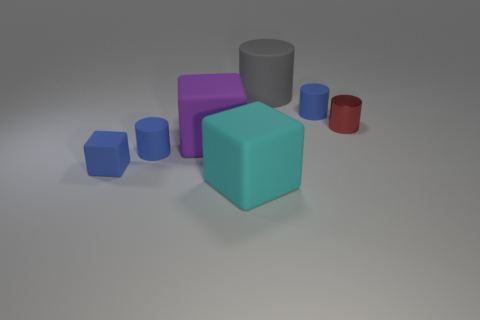Is there another large thing of the same shape as the big purple matte thing?
Your answer should be compact. Yes. How many large purple objects are there?
Give a very brief answer. 1. What shape is the large purple matte thing?
Your answer should be compact. Cube. What number of other objects have the same size as the red metal thing?
Ensure brevity in your answer.  3. Does the large purple matte object have the same shape as the gray matte object?
Give a very brief answer. No. What is the color of the block behind the tiny blue cylinder that is to the left of the purple matte block?
Give a very brief answer. Purple. There is a block that is both in front of the large purple matte cube and behind the large cyan rubber cube; what is its size?
Your response must be concise. Small. Is there any other thing that has the same color as the small cube?
Ensure brevity in your answer.  Yes. There is a large gray thing that is the same material as the blue cube; what shape is it?
Ensure brevity in your answer.  Cylinder. Is the shape of the cyan rubber thing the same as the big object that is left of the cyan thing?
Keep it short and to the point. Yes. 